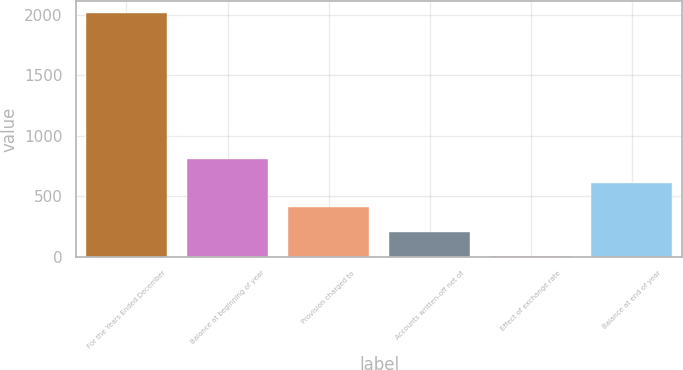Convert chart. <chart><loc_0><loc_0><loc_500><loc_500><bar_chart><fcel>For the Years Ended December<fcel>Balance at beginning of year<fcel>Provision charged to<fcel>Accounts written-off net of<fcel>Effect of exchange rate<fcel>Balance at end of year<nl><fcel>2014<fcel>809.2<fcel>407.6<fcel>206.8<fcel>6<fcel>608.4<nl></chart> 